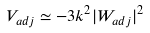<formula> <loc_0><loc_0><loc_500><loc_500>V _ { a d j } \simeq - 3 k ^ { 2 } | W _ { a d j } | ^ { 2 }</formula> 